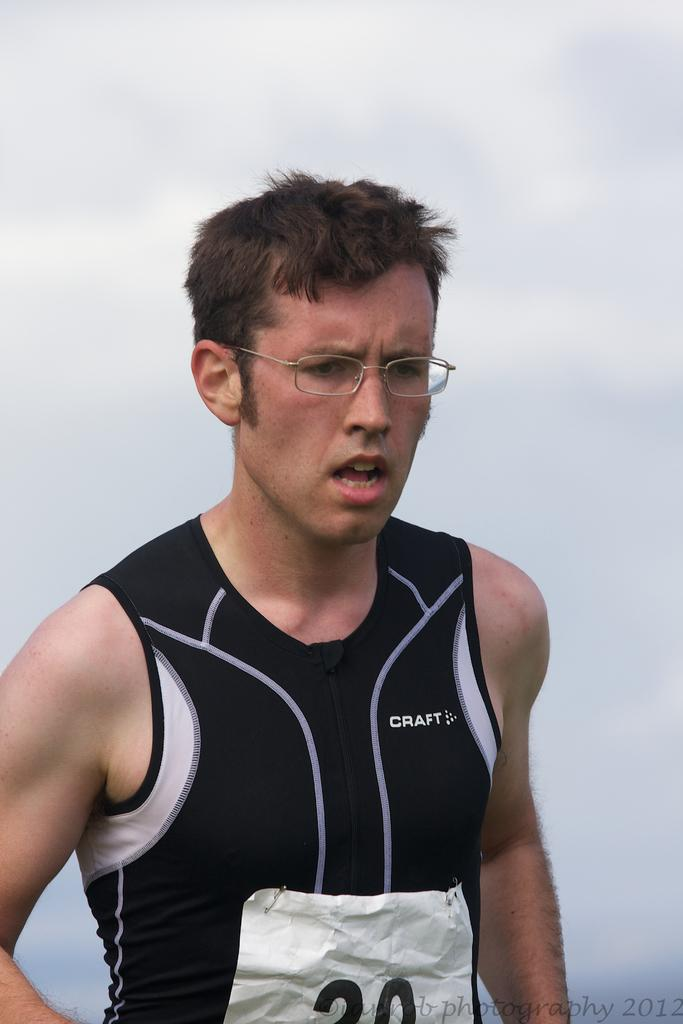<image>
Describe the image concisely. A race runner wearing a Craft shirt and a number 20 race number. 